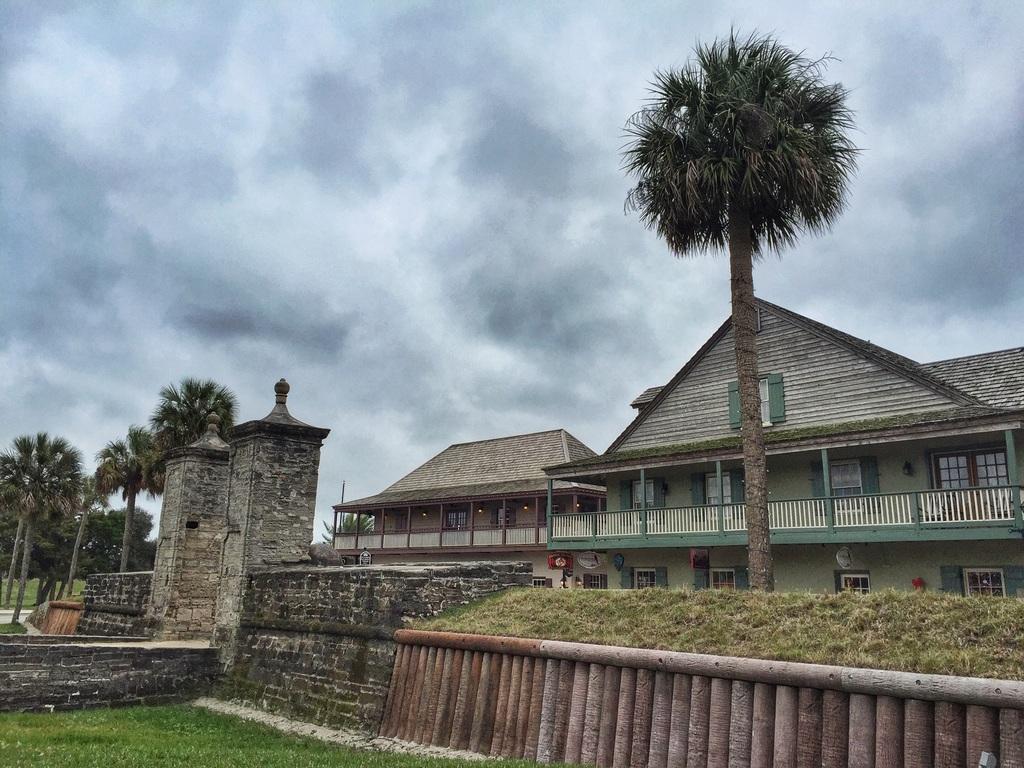Please provide a concise description of this image. This picture is clicked outside. In the foreground we can see the green grass and a metal fence. In the center there is a building and trees. In the background there is a sky which is full of clouds. 